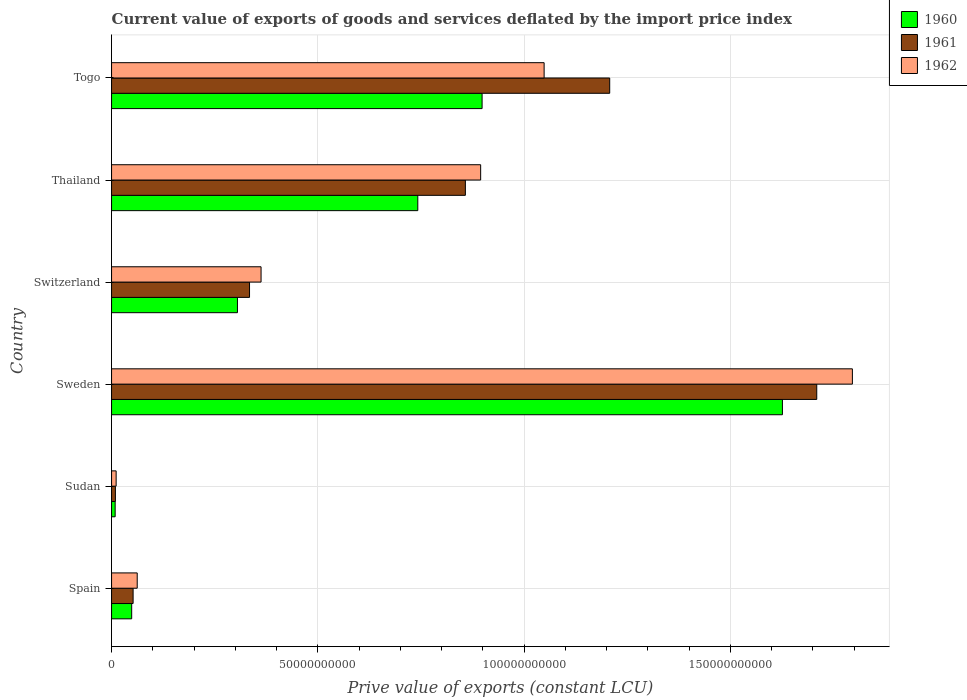How many groups of bars are there?
Ensure brevity in your answer.  6. Are the number of bars per tick equal to the number of legend labels?
Ensure brevity in your answer.  Yes. How many bars are there on the 3rd tick from the bottom?
Offer a very short reply. 3. What is the label of the 1st group of bars from the top?
Your answer should be very brief. Togo. What is the prive value of exports in 1961 in Thailand?
Your response must be concise. 8.58e+1. Across all countries, what is the maximum prive value of exports in 1961?
Provide a succinct answer. 1.71e+11. Across all countries, what is the minimum prive value of exports in 1960?
Your answer should be compact. 8.72e+08. In which country was the prive value of exports in 1962 maximum?
Provide a short and direct response. Sweden. In which country was the prive value of exports in 1962 minimum?
Make the answer very short. Sudan. What is the total prive value of exports in 1961 in the graph?
Offer a very short reply. 4.17e+11. What is the difference between the prive value of exports in 1961 in Sweden and that in Switzerland?
Offer a terse response. 1.37e+11. What is the difference between the prive value of exports in 1961 in Thailand and the prive value of exports in 1960 in Switzerland?
Make the answer very short. 5.52e+1. What is the average prive value of exports in 1962 per country?
Offer a very short reply. 6.96e+1. What is the difference between the prive value of exports in 1960 and prive value of exports in 1962 in Sudan?
Offer a terse response. -2.38e+08. What is the ratio of the prive value of exports in 1962 in Sweden to that in Switzerland?
Provide a short and direct response. 4.96. Is the prive value of exports in 1961 in Spain less than that in Sweden?
Make the answer very short. Yes. What is the difference between the highest and the second highest prive value of exports in 1962?
Provide a short and direct response. 7.47e+1. What is the difference between the highest and the lowest prive value of exports in 1960?
Provide a short and direct response. 1.62e+11. What does the 3rd bar from the top in Togo represents?
Provide a short and direct response. 1960. What does the 3rd bar from the bottom in Thailand represents?
Provide a short and direct response. 1962. How many bars are there?
Make the answer very short. 18. Are all the bars in the graph horizontal?
Ensure brevity in your answer.  Yes. Does the graph contain any zero values?
Your response must be concise. No. Does the graph contain grids?
Keep it short and to the point. Yes. Where does the legend appear in the graph?
Give a very brief answer. Top right. How many legend labels are there?
Offer a very short reply. 3. What is the title of the graph?
Provide a succinct answer. Current value of exports of goods and services deflated by the import price index. Does "1980" appear as one of the legend labels in the graph?
Offer a very short reply. No. What is the label or title of the X-axis?
Offer a terse response. Prive value of exports (constant LCU). What is the Prive value of exports (constant LCU) of 1960 in Spain?
Provide a short and direct response. 4.88e+09. What is the Prive value of exports (constant LCU) in 1961 in Spain?
Ensure brevity in your answer.  5.23e+09. What is the Prive value of exports (constant LCU) of 1962 in Spain?
Make the answer very short. 6.22e+09. What is the Prive value of exports (constant LCU) of 1960 in Sudan?
Provide a short and direct response. 8.72e+08. What is the Prive value of exports (constant LCU) in 1961 in Sudan?
Offer a terse response. 9.32e+08. What is the Prive value of exports (constant LCU) of 1962 in Sudan?
Provide a succinct answer. 1.11e+09. What is the Prive value of exports (constant LCU) of 1960 in Sweden?
Offer a terse response. 1.63e+11. What is the Prive value of exports (constant LCU) of 1961 in Sweden?
Make the answer very short. 1.71e+11. What is the Prive value of exports (constant LCU) of 1962 in Sweden?
Offer a terse response. 1.80e+11. What is the Prive value of exports (constant LCU) in 1960 in Switzerland?
Provide a short and direct response. 3.05e+1. What is the Prive value of exports (constant LCU) in 1961 in Switzerland?
Offer a terse response. 3.34e+1. What is the Prive value of exports (constant LCU) of 1962 in Switzerland?
Make the answer very short. 3.62e+1. What is the Prive value of exports (constant LCU) in 1960 in Thailand?
Provide a succinct answer. 7.42e+1. What is the Prive value of exports (constant LCU) of 1961 in Thailand?
Offer a very short reply. 8.58e+1. What is the Prive value of exports (constant LCU) of 1962 in Thailand?
Give a very brief answer. 8.95e+1. What is the Prive value of exports (constant LCU) in 1960 in Togo?
Offer a very short reply. 8.98e+1. What is the Prive value of exports (constant LCU) of 1961 in Togo?
Ensure brevity in your answer.  1.21e+11. What is the Prive value of exports (constant LCU) of 1962 in Togo?
Your answer should be compact. 1.05e+11. Across all countries, what is the maximum Prive value of exports (constant LCU) in 1960?
Offer a terse response. 1.63e+11. Across all countries, what is the maximum Prive value of exports (constant LCU) of 1961?
Offer a terse response. 1.71e+11. Across all countries, what is the maximum Prive value of exports (constant LCU) in 1962?
Give a very brief answer. 1.80e+11. Across all countries, what is the minimum Prive value of exports (constant LCU) in 1960?
Offer a very short reply. 8.72e+08. Across all countries, what is the minimum Prive value of exports (constant LCU) of 1961?
Make the answer very short. 9.32e+08. Across all countries, what is the minimum Prive value of exports (constant LCU) of 1962?
Give a very brief answer. 1.11e+09. What is the total Prive value of exports (constant LCU) of 1960 in the graph?
Make the answer very short. 3.63e+11. What is the total Prive value of exports (constant LCU) of 1961 in the graph?
Your answer should be very brief. 4.17e+11. What is the total Prive value of exports (constant LCU) of 1962 in the graph?
Your answer should be very brief. 4.17e+11. What is the difference between the Prive value of exports (constant LCU) of 1960 in Spain and that in Sudan?
Ensure brevity in your answer.  4.00e+09. What is the difference between the Prive value of exports (constant LCU) of 1961 in Spain and that in Sudan?
Make the answer very short. 4.29e+09. What is the difference between the Prive value of exports (constant LCU) in 1962 in Spain and that in Sudan?
Your answer should be very brief. 5.11e+09. What is the difference between the Prive value of exports (constant LCU) in 1960 in Spain and that in Sweden?
Give a very brief answer. -1.58e+11. What is the difference between the Prive value of exports (constant LCU) in 1961 in Spain and that in Sweden?
Offer a terse response. -1.66e+11. What is the difference between the Prive value of exports (constant LCU) of 1962 in Spain and that in Sweden?
Ensure brevity in your answer.  -1.73e+11. What is the difference between the Prive value of exports (constant LCU) in 1960 in Spain and that in Switzerland?
Give a very brief answer. -2.56e+1. What is the difference between the Prive value of exports (constant LCU) in 1961 in Spain and that in Switzerland?
Give a very brief answer. -2.82e+1. What is the difference between the Prive value of exports (constant LCU) in 1962 in Spain and that in Switzerland?
Give a very brief answer. -3.00e+1. What is the difference between the Prive value of exports (constant LCU) in 1960 in Spain and that in Thailand?
Provide a succinct answer. -6.94e+1. What is the difference between the Prive value of exports (constant LCU) of 1961 in Spain and that in Thailand?
Your answer should be compact. -8.05e+1. What is the difference between the Prive value of exports (constant LCU) in 1962 in Spain and that in Thailand?
Your answer should be very brief. -8.32e+1. What is the difference between the Prive value of exports (constant LCU) in 1960 in Spain and that in Togo?
Your answer should be very brief. -8.49e+1. What is the difference between the Prive value of exports (constant LCU) in 1961 in Spain and that in Togo?
Make the answer very short. -1.16e+11. What is the difference between the Prive value of exports (constant LCU) in 1962 in Spain and that in Togo?
Provide a short and direct response. -9.86e+1. What is the difference between the Prive value of exports (constant LCU) in 1960 in Sudan and that in Sweden?
Your response must be concise. -1.62e+11. What is the difference between the Prive value of exports (constant LCU) of 1961 in Sudan and that in Sweden?
Offer a very short reply. -1.70e+11. What is the difference between the Prive value of exports (constant LCU) of 1962 in Sudan and that in Sweden?
Provide a short and direct response. -1.78e+11. What is the difference between the Prive value of exports (constant LCU) of 1960 in Sudan and that in Switzerland?
Keep it short and to the point. -2.96e+1. What is the difference between the Prive value of exports (constant LCU) in 1961 in Sudan and that in Switzerland?
Offer a terse response. -3.25e+1. What is the difference between the Prive value of exports (constant LCU) in 1962 in Sudan and that in Switzerland?
Keep it short and to the point. -3.51e+1. What is the difference between the Prive value of exports (constant LCU) of 1960 in Sudan and that in Thailand?
Provide a short and direct response. -7.34e+1. What is the difference between the Prive value of exports (constant LCU) of 1961 in Sudan and that in Thailand?
Provide a short and direct response. -8.48e+1. What is the difference between the Prive value of exports (constant LCU) in 1962 in Sudan and that in Thailand?
Ensure brevity in your answer.  -8.84e+1. What is the difference between the Prive value of exports (constant LCU) of 1960 in Sudan and that in Togo?
Offer a terse response. -8.89e+1. What is the difference between the Prive value of exports (constant LCU) of 1961 in Sudan and that in Togo?
Make the answer very short. -1.20e+11. What is the difference between the Prive value of exports (constant LCU) of 1962 in Sudan and that in Togo?
Give a very brief answer. -1.04e+11. What is the difference between the Prive value of exports (constant LCU) in 1960 in Sweden and that in Switzerland?
Provide a short and direct response. 1.32e+11. What is the difference between the Prive value of exports (constant LCU) of 1961 in Sweden and that in Switzerland?
Your response must be concise. 1.37e+11. What is the difference between the Prive value of exports (constant LCU) in 1962 in Sweden and that in Switzerland?
Ensure brevity in your answer.  1.43e+11. What is the difference between the Prive value of exports (constant LCU) in 1960 in Sweden and that in Thailand?
Offer a terse response. 8.84e+1. What is the difference between the Prive value of exports (constant LCU) in 1961 in Sweden and that in Thailand?
Offer a very short reply. 8.52e+1. What is the difference between the Prive value of exports (constant LCU) in 1962 in Sweden and that in Thailand?
Offer a very short reply. 9.01e+1. What is the difference between the Prive value of exports (constant LCU) of 1960 in Sweden and that in Togo?
Your answer should be compact. 7.28e+1. What is the difference between the Prive value of exports (constant LCU) of 1961 in Sweden and that in Togo?
Ensure brevity in your answer.  5.02e+1. What is the difference between the Prive value of exports (constant LCU) in 1962 in Sweden and that in Togo?
Make the answer very short. 7.47e+1. What is the difference between the Prive value of exports (constant LCU) in 1960 in Switzerland and that in Thailand?
Give a very brief answer. -4.37e+1. What is the difference between the Prive value of exports (constant LCU) of 1961 in Switzerland and that in Thailand?
Make the answer very short. -5.23e+1. What is the difference between the Prive value of exports (constant LCU) of 1962 in Switzerland and that in Thailand?
Make the answer very short. -5.32e+1. What is the difference between the Prive value of exports (constant LCU) in 1960 in Switzerland and that in Togo?
Make the answer very short. -5.93e+1. What is the difference between the Prive value of exports (constant LCU) in 1961 in Switzerland and that in Togo?
Provide a succinct answer. -8.73e+1. What is the difference between the Prive value of exports (constant LCU) in 1962 in Switzerland and that in Togo?
Offer a terse response. -6.86e+1. What is the difference between the Prive value of exports (constant LCU) of 1960 in Thailand and that in Togo?
Keep it short and to the point. -1.56e+1. What is the difference between the Prive value of exports (constant LCU) of 1961 in Thailand and that in Togo?
Your answer should be compact. -3.50e+1. What is the difference between the Prive value of exports (constant LCU) of 1962 in Thailand and that in Togo?
Provide a short and direct response. -1.54e+1. What is the difference between the Prive value of exports (constant LCU) in 1960 in Spain and the Prive value of exports (constant LCU) in 1961 in Sudan?
Your answer should be very brief. 3.95e+09. What is the difference between the Prive value of exports (constant LCU) in 1960 in Spain and the Prive value of exports (constant LCU) in 1962 in Sudan?
Give a very brief answer. 3.77e+09. What is the difference between the Prive value of exports (constant LCU) in 1961 in Spain and the Prive value of exports (constant LCU) in 1962 in Sudan?
Keep it short and to the point. 4.11e+09. What is the difference between the Prive value of exports (constant LCU) in 1960 in Spain and the Prive value of exports (constant LCU) in 1961 in Sweden?
Give a very brief answer. -1.66e+11. What is the difference between the Prive value of exports (constant LCU) in 1960 in Spain and the Prive value of exports (constant LCU) in 1962 in Sweden?
Keep it short and to the point. -1.75e+11. What is the difference between the Prive value of exports (constant LCU) of 1961 in Spain and the Prive value of exports (constant LCU) of 1962 in Sweden?
Provide a succinct answer. -1.74e+11. What is the difference between the Prive value of exports (constant LCU) in 1960 in Spain and the Prive value of exports (constant LCU) in 1961 in Switzerland?
Your answer should be very brief. -2.86e+1. What is the difference between the Prive value of exports (constant LCU) in 1960 in Spain and the Prive value of exports (constant LCU) in 1962 in Switzerland?
Provide a succinct answer. -3.14e+1. What is the difference between the Prive value of exports (constant LCU) in 1961 in Spain and the Prive value of exports (constant LCU) in 1962 in Switzerland?
Your answer should be very brief. -3.10e+1. What is the difference between the Prive value of exports (constant LCU) in 1960 in Spain and the Prive value of exports (constant LCU) in 1961 in Thailand?
Offer a terse response. -8.09e+1. What is the difference between the Prive value of exports (constant LCU) in 1960 in Spain and the Prive value of exports (constant LCU) in 1962 in Thailand?
Your answer should be very brief. -8.46e+1. What is the difference between the Prive value of exports (constant LCU) in 1961 in Spain and the Prive value of exports (constant LCU) in 1962 in Thailand?
Offer a very short reply. -8.42e+1. What is the difference between the Prive value of exports (constant LCU) in 1960 in Spain and the Prive value of exports (constant LCU) in 1961 in Togo?
Your answer should be compact. -1.16e+11. What is the difference between the Prive value of exports (constant LCU) in 1960 in Spain and the Prive value of exports (constant LCU) in 1962 in Togo?
Offer a very short reply. -1.00e+11. What is the difference between the Prive value of exports (constant LCU) in 1961 in Spain and the Prive value of exports (constant LCU) in 1962 in Togo?
Offer a very short reply. -9.96e+1. What is the difference between the Prive value of exports (constant LCU) in 1960 in Sudan and the Prive value of exports (constant LCU) in 1961 in Sweden?
Ensure brevity in your answer.  -1.70e+11. What is the difference between the Prive value of exports (constant LCU) of 1960 in Sudan and the Prive value of exports (constant LCU) of 1962 in Sweden?
Offer a very short reply. -1.79e+11. What is the difference between the Prive value of exports (constant LCU) in 1961 in Sudan and the Prive value of exports (constant LCU) in 1962 in Sweden?
Offer a terse response. -1.79e+11. What is the difference between the Prive value of exports (constant LCU) in 1960 in Sudan and the Prive value of exports (constant LCU) in 1961 in Switzerland?
Provide a succinct answer. -3.26e+1. What is the difference between the Prive value of exports (constant LCU) in 1960 in Sudan and the Prive value of exports (constant LCU) in 1962 in Switzerland?
Your response must be concise. -3.54e+1. What is the difference between the Prive value of exports (constant LCU) in 1961 in Sudan and the Prive value of exports (constant LCU) in 1962 in Switzerland?
Offer a terse response. -3.53e+1. What is the difference between the Prive value of exports (constant LCU) of 1960 in Sudan and the Prive value of exports (constant LCU) of 1961 in Thailand?
Provide a succinct answer. -8.49e+1. What is the difference between the Prive value of exports (constant LCU) in 1960 in Sudan and the Prive value of exports (constant LCU) in 1962 in Thailand?
Your response must be concise. -8.86e+1. What is the difference between the Prive value of exports (constant LCU) in 1961 in Sudan and the Prive value of exports (constant LCU) in 1962 in Thailand?
Ensure brevity in your answer.  -8.85e+1. What is the difference between the Prive value of exports (constant LCU) in 1960 in Sudan and the Prive value of exports (constant LCU) in 1961 in Togo?
Make the answer very short. -1.20e+11. What is the difference between the Prive value of exports (constant LCU) of 1960 in Sudan and the Prive value of exports (constant LCU) of 1962 in Togo?
Your answer should be compact. -1.04e+11. What is the difference between the Prive value of exports (constant LCU) of 1961 in Sudan and the Prive value of exports (constant LCU) of 1962 in Togo?
Provide a short and direct response. -1.04e+11. What is the difference between the Prive value of exports (constant LCU) in 1960 in Sweden and the Prive value of exports (constant LCU) in 1961 in Switzerland?
Give a very brief answer. 1.29e+11. What is the difference between the Prive value of exports (constant LCU) of 1960 in Sweden and the Prive value of exports (constant LCU) of 1962 in Switzerland?
Give a very brief answer. 1.26e+11. What is the difference between the Prive value of exports (constant LCU) in 1961 in Sweden and the Prive value of exports (constant LCU) in 1962 in Switzerland?
Provide a short and direct response. 1.35e+11. What is the difference between the Prive value of exports (constant LCU) of 1960 in Sweden and the Prive value of exports (constant LCU) of 1961 in Thailand?
Your answer should be compact. 7.69e+1. What is the difference between the Prive value of exports (constant LCU) of 1960 in Sweden and the Prive value of exports (constant LCU) of 1962 in Thailand?
Keep it short and to the point. 7.31e+1. What is the difference between the Prive value of exports (constant LCU) of 1961 in Sweden and the Prive value of exports (constant LCU) of 1962 in Thailand?
Ensure brevity in your answer.  8.15e+1. What is the difference between the Prive value of exports (constant LCU) in 1960 in Sweden and the Prive value of exports (constant LCU) in 1961 in Togo?
Make the answer very short. 4.19e+1. What is the difference between the Prive value of exports (constant LCU) of 1960 in Sweden and the Prive value of exports (constant LCU) of 1962 in Togo?
Ensure brevity in your answer.  5.78e+1. What is the difference between the Prive value of exports (constant LCU) of 1961 in Sweden and the Prive value of exports (constant LCU) of 1962 in Togo?
Your answer should be compact. 6.61e+1. What is the difference between the Prive value of exports (constant LCU) of 1960 in Switzerland and the Prive value of exports (constant LCU) of 1961 in Thailand?
Your answer should be compact. -5.52e+1. What is the difference between the Prive value of exports (constant LCU) of 1960 in Switzerland and the Prive value of exports (constant LCU) of 1962 in Thailand?
Your answer should be very brief. -5.89e+1. What is the difference between the Prive value of exports (constant LCU) of 1961 in Switzerland and the Prive value of exports (constant LCU) of 1962 in Thailand?
Your answer should be compact. -5.60e+1. What is the difference between the Prive value of exports (constant LCU) in 1960 in Switzerland and the Prive value of exports (constant LCU) in 1961 in Togo?
Offer a very short reply. -9.02e+1. What is the difference between the Prive value of exports (constant LCU) of 1960 in Switzerland and the Prive value of exports (constant LCU) of 1962 in Togo?
Your response must be concise. -7.43e+1. What is the difference between the Prive value of exports (constant LCU) of 1961 in Switzerland and the Prive value of exports (constant LCU) of 1962 in Togo?
Your answer should be compact. -7.14e+1. What is the difference between the Prive value of exports (constant LCU) in 1960 in Thailand and the Prive value of exports (constant LCU) in 1961 in Togo?
Provide a short and direct response. -4.65e+1. What is the difference between the Prive value of exports (constant LCU) in 1960 in Thailand and the Prive value of exports (constant LCU) in 1962 in Togo?
Give a very brief answer. -3.06e+1. What is the difference between the Prive value of exports (constant LCU) in 1961 in Thailand and the Prive value of exports (constant LCU) in 1962 in Togo?
Give a very brief answer. -1.91e+1. What is the average Prive value of exports (constant LCU) of 1960 per country?
Offer a terse response. 6.05e+1. What is the average Prive value of exports (constant LCU) in 1961 per country?
Keep it short and to the point. 6.95e+1. What is the average Prive value of exports (constant LCU) in 1962 per country?
Provide a succinct answer. 6.96e+1. What is the difference between the Prive value of exports (constant LCU) in 1960 and Prive value of exports (constant LCU) in 1961 in Spain?
Your answer should be compact. -3.48e+08. What is the difference between the Prive value of exports (constant LCU) of 1960 and Prive value of exports (constant LCU) of 1962 in Spain?
Keep it short and to the point. -1.34e+09. What is the difference between the Prive value of exports (constant LCU) of 1961 and Prive value of exports (constant LCU) of 1962 in Spain?
Your response must be concise. -9.94e+08. What is the difference between the Prive value of exports (constant LCU) in 1960 and Prive value of exports (constant LCU) in 1961 in Sudan?
Provide a short and direct response. -5.96e+07. What is the difference between the Prive value of exports (constant LCU) in 1960 and Prive value of exports (constant LCU) in 1962 in Sudan?
Offer a terse response. -2.38e+08. What is the difference between the Prive value of exports (constant LCU) of 1961 and Prive value of exports (constant LCU) of 1962 in Sudan?
Keep it short and to the point. -1.79e+08. What is the difference between the Prive value of exports (constant LCU) in 1960 and Prive value of exports (constant LCU) in 1961 in Sweden?
Provide a short and direct response. -8.32e+09. What is the difference between the Prive value of exports (constant LCU) in 1960 and Prive value of exports (constant LCU) in 1962 in Sweden?
Provide a short and direct response. -1.70e+1. What is the difference between the Prive value of exports (constant LCU) in 1961 and Prive value of exports (constant LCU) in 1962 in Sweden?
Offer a terse response. -8.64e+09. What is the difference between the Prive value of exports (constant LCU) in 1960 and Prive value of exports (constant LCU) in 1961 in Switzerland?
Offer a very short reply. -2.93e+09. What is the difference between the Prive value of exports (constant LCU) in 1960 and Prive value of exports (constant LCU) in 1962 in Switzerland?
Provide a short and direct response. -5.72e+09. What is the difference between the Prive value of exports (constant LCU) in 1961 and Prive value of exports (constant LCU) in 1962 in Switzerland?
Ensure brevity in your answer.  -2.79e+09. What is the difference between the Prive value of exports (constant LCU) of 1960 and Prive value of exports (constant LCU) of 1961 in Thailand?
Your response must be concise. -1.15e+1. What is the difference between the Prive value of exports (constant LCU) in 1960 and Prive value of exports (constant LCU) in 1962 in Thailand?
Your answer should be very brief. -1.52e+1. What is the difference between the Prive value of exports (constant LCU) in 1961 and Prive value of exports (constant LCU) in 1962 in Thailand?
Your answer should be compact. -3.71e+09. What is the difference between the Prive value of exports (constant LCU) of 1960 and Prive value of exports (constant LCU) of 1961 in Togo?
Provide a short and direct response. -3.09e+1. What is the difference between the Prive value of exports (constant LCU) of 1960 and Prive value of exports (constant LCU) of 1962 in Togo?
Make the answer very short. -1.50e+1. What is the difference between the Prive value of exports (constant LCU) in 1961 and Prive value of exports (constant LCU) in 1962 in Togo?
Your answer should be very brief. 1.59e+1. What is the ratio of the Prive value of exports (constant LCU) of 1960 in Spain to that in Sudan?
Ensure brevity in your answer.  5.59. What is the ratio of the Prive value of exports (constant LCU) of 1961 in Spain to that in Sudan?
Offer a terse response. 5.61. What is the ratio of the Prive value of exports (constant LCU) of 1962 in Spain to that in Sudan?
Ensure brevity in your answer.  5.6. What is the ratio of the Prive value of exports (constant LCU) of 1960 in Spain to that in Sweden?
Your response must be concise. 0.03. What is the ratio of the Prive value of exports (constant LCU) of 1961 in Spain to that in Sweden?
Keep it short and to the point. 0.03. What is the ratio of the Prive value of exports (constant LCU) of 1962 in Spain to that in Sweden?
Offer a very short reply. 0.03. What is the ratio of the Prive value of exports (constant LCU) of 1960 in Spain to that in Switzerland?
Give a very brief answer. 0.16. What is the ratio of the Prive value of exports (constant LCU) of 1961 in Spain to that in Switzerland?
Ensure brevity in your answer.  0.16. What is the ratio of the Prive value of exports (constant LCU) of 1962 in Spain to that in Switzerland?
Ensure brevity in your answer.  0.17. What is the ratio of the Prive value of exports (constant LCU) of 1960 in Spain to that in Thailand?
Provide a short and direct response. 0.07. What is the ratio of the Prive value of exports (constant LCU) in 1961 in Spain to that in Thailand?
Provide a succinct answer. 0.06. What is the ratio of the Prive value of exports (constant LCU) of 1962 in Spain to that in Thailand?
Keep it short and to the point. 0.07. What is the ratio of the Prive value of exports (constant LCU) of 1960 in Spain to that in Togo?
Keep it short and to the point. 0.05. What is the ratio of the Prive value of exports (constant LCU) in 1961 in Spain to that in Togo?
Provide a succinct answer. 0.04. What is the ratio of the Prive value of exports (constant LCU) in 1962 in Spain to that in Togo?
Offer a very short reply. 0.06. What is the ratio of the Prive value of exports (constant LCU) of 1960 in Sudan to that in Sweden?
Provide a short and direct response. 0.01. What is the ratio of the Prive value of exports (constant LCU) in 1961 in Sudan to that in Sweden?
Your answer should be very brief. 0.01. What is the ratio of the Prive value of exports (constant LCU) of 1962 in Sudan to that in Sweden?
Offer a terse response. 0.01. What is the ratio of the Prive value of exports (constant LCU) in 1960 in Sudan to that in Switzerland?
Your answer should be compact. 0.03. What is the ratio of the Prive value of exports (constant LCU) of 1961 in Sudan to that in Switzerland?
Keep it short and to the point. 0.03. What is the ratio of the Prive value of exports (constant LCU) of 1962 in Sudan to that in Switzerland?
Offer a very short reply. 0.03. What is the ratio of the Prive value of exports (constant LCU) in 1960 in Sudan to that in Thailand?
Keep it short and to the point. 0.01. What is the ratio of the Prive value of exports (constant LCU) of 1961 in Sudan to that in Thailand?
Offer a terse response. 0.01. What is the ratio of the Prive value of exports (constant LCU) of 1962 in Sudan to that in Thailand?
Offer a terse response. 0.01. What is the ratio of the Prive value of exports (constant LCU) in 1960 in Sudan to that in Togo?
Your answer should be very brief. 0.01. What is the ratio of the Prive value of exports (constant LCU) in 1961 in Sudan to that in Togo?
Offer a very short reply. 0.01. What is the ratio of the Prive value of exports (constant LCU) of 1962 in Sudan to that in Togo?
Keep it short and to the point. 0.01. What is the ratio of the Prive value of exports (constant LCU) of 1960 in Sweden to that in Switzerland?
Your answer should be very brief. 5.33. What is the ratio of the Prive value of exports (constant LCU) of 1961 in Sweden to that in Switzerland?
Your answer should be compact. 5.11. What is the ratio of the Prive value of exports (constant LCU) of 1962 in Sweden to that in Switzerland?
Your answer should be compact. 4.96. What is the ratio of the Prive value of exports (constant LCU) of 1960 in Sweden to that in Thailand?
Give a very brief answer. 2.19. What is the ratio of the Prive value of exports (constant LCU) in 1961 in Sweden to that in Thailand?
Keep it short and to the point. 1.99. What is the ratio of the Prive value of exports (constant LCU) in 1962 in Sweden to that in Thailand?
Give a very brief answer. 2.01. What is the ratio of the Prive value of exports (constant LCU) of 1960 in Sweden to that in Togo?
Ensure brevity in your answer.  1.81. What is the ratio of the Prive value of exports (constant LCU) in 1961 in Sweden to that in Togo?
Your answer should be very brief. 1.42. What is the ratio of the Prive value of exports (constant LCU) of 1962 in Sweden to that in Togo?
Provide a succinct answer. 1.71. What is the ratio of the Prive value of exports (constant LCU) in 1960 in Switzerland to that in Thailand?
Make the answer very short. 0.41. What is the ratio of the Prive value of exports (constant LCU) in 1961 in Switzerland to that in Thailand?
Offer a very short reply. 0.39. What is the ratio of the Prive value of exports (constant LCU) of 1962 in Switzerland to that in Thailand?
Your answer should be very brief. 0.41. What is the ratio of the Prive value of exports (constant LCU) in 1960 in Switzerland to that in Togo?
Provide a short and direct response. 0.34. What is the ratio of the Prive value of exports (constant LCU) of 1961 in Switzerland to that in Togo?
Give a very brief answer. 0.28. What is the ratio of the Prive value of exports (constant LCU) in 1962 in Switzerland to that in Togo?
Make the answer very short. 0.35. What is the ratio of the Prive value of exports (constant LCU) in 1960 in Thailand to that in Togo?
Your answer should be compact. 0.83. What is the ratio of the Prive value of exports (constant LCU) of 1961 in Thailand to that in Togo?
Offer a very short reply. 0.71. What is the ratio of the Prive value of exports (constant LCU) in 1962 in Thailand to that in Togo?
Provide a short and direct response. 0.85. What is the difference between the highest and the second highest Prive value of exports (constant LCU) in 1960?
Make the answer very short. 7.28e+1. What is the difference between the highest and the second highest Prive value of exports (constant LCU) of 1961?
Keep it short and to the point. 5.02e+1. What is the difference between the highest and the second highest Prive value of exports (constant LCU) of 1962?
Offer a terse response. 7.47e+1. What is the difference between the highest and the lowest Prive value of exports (constant LCU) in 1960?
Your response must be concise. 1.62e+11. What is the difference between the highest and the lowest Prive value of exports (constant LCU) in 1961?
Keep it short and to the point. 1.70e+11. What is the difference between the highest and the lowest Prive value of exports (constant LCU) in 1962?
Ensure brevity in your answer.  1.78e+11. 